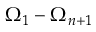Convert formula to latex. <formula><loc_0><loc_0><loc_500><loc_500>\Omega _ { 1 } - \Omega _ { n + 1 }</formula> 